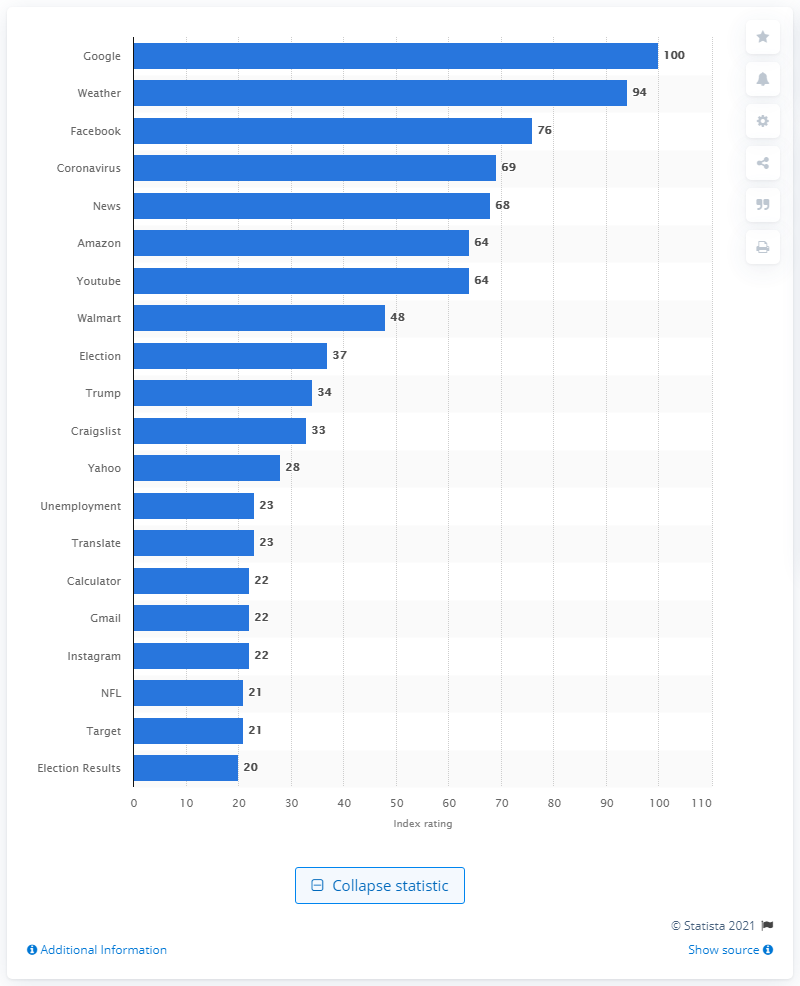Identify some key points in this picture. As of December 31st, 2020, the index value for "Weather" reached 94. 